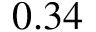Convert formula to latex. <formula><loc_0><loc_0><loc_500><loc_500>0 . 3 4</formula> 